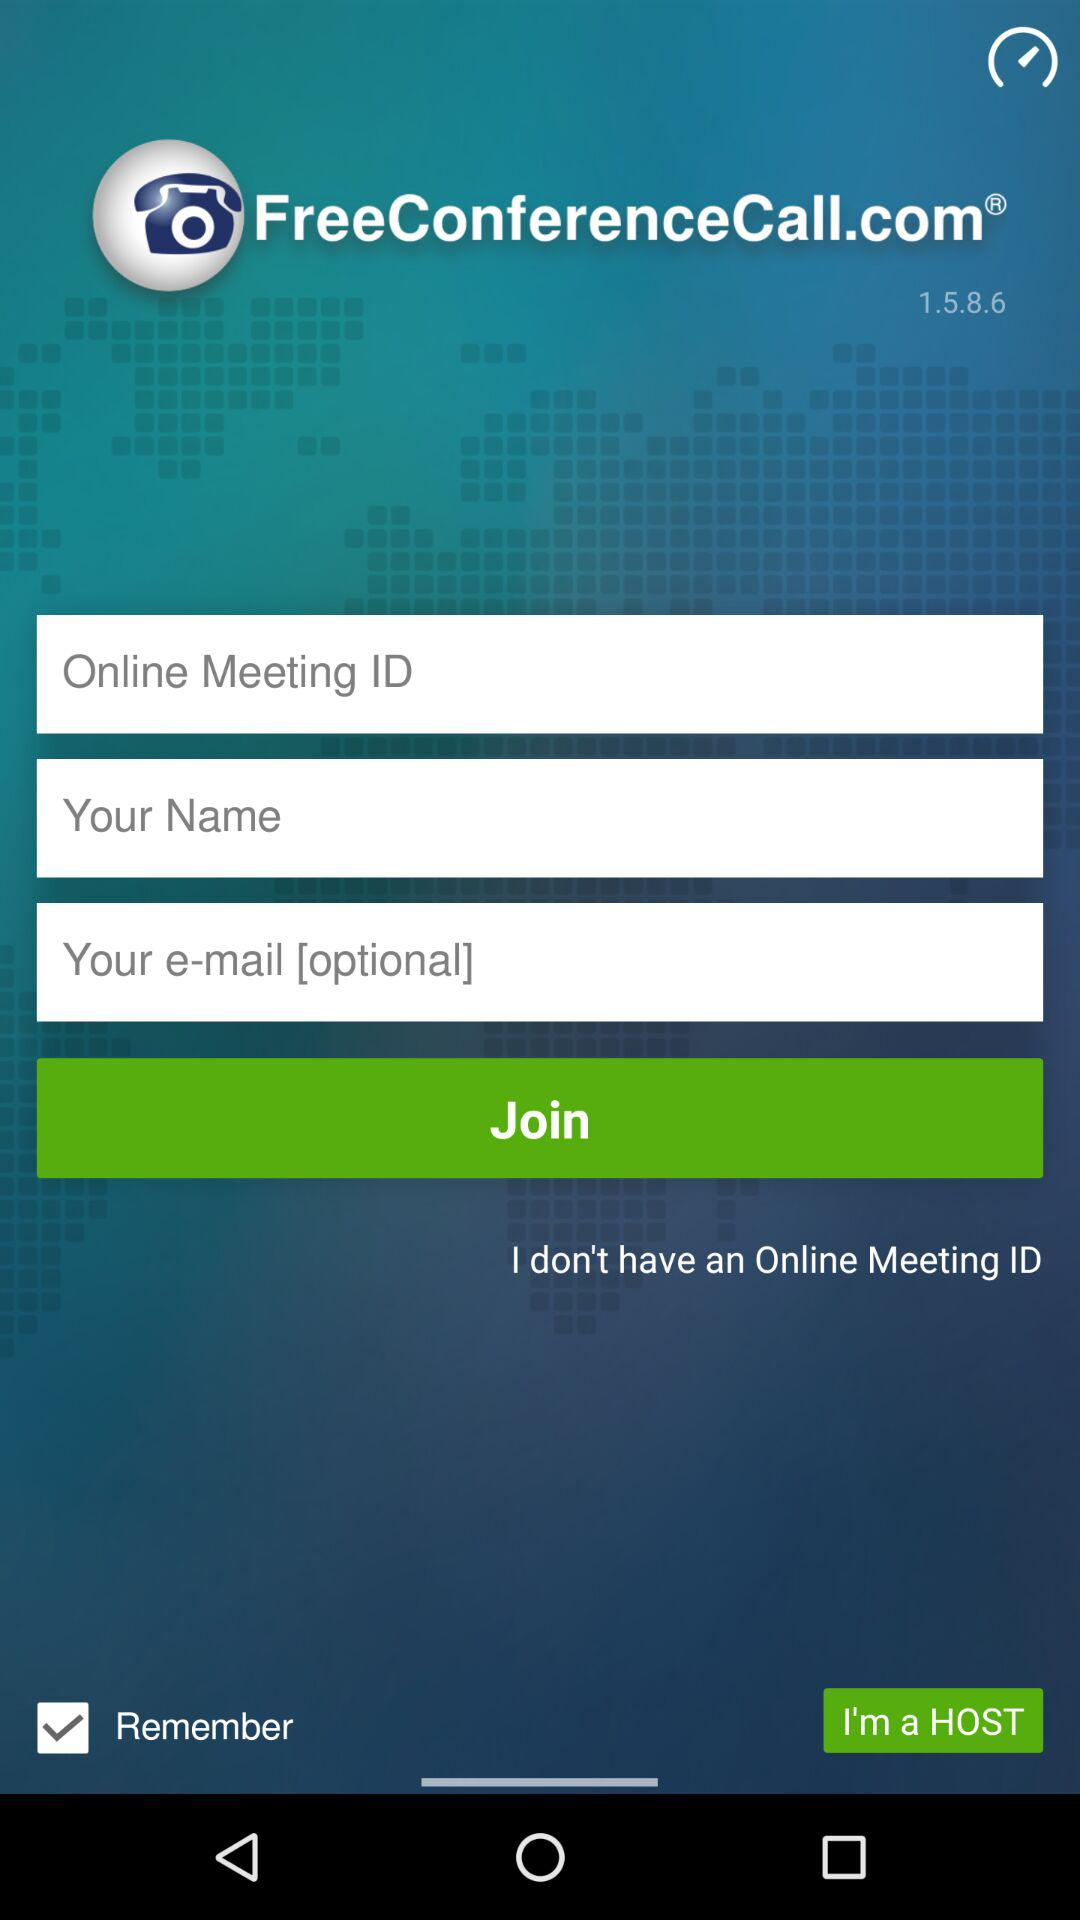What is the status of "Remember"? The status is "on". 